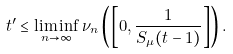Convert formula to latex. <formula><loc_0><loc_0><loc_500><loc_500>t ^ { \prime } & \leq \liminf _ { n \to \infty } \nu _ { n } \left ( \left [ 0 , \frac { 1 } { S _ { \mu } ( t - 1 ) } \right ] \right ) .</formula> 